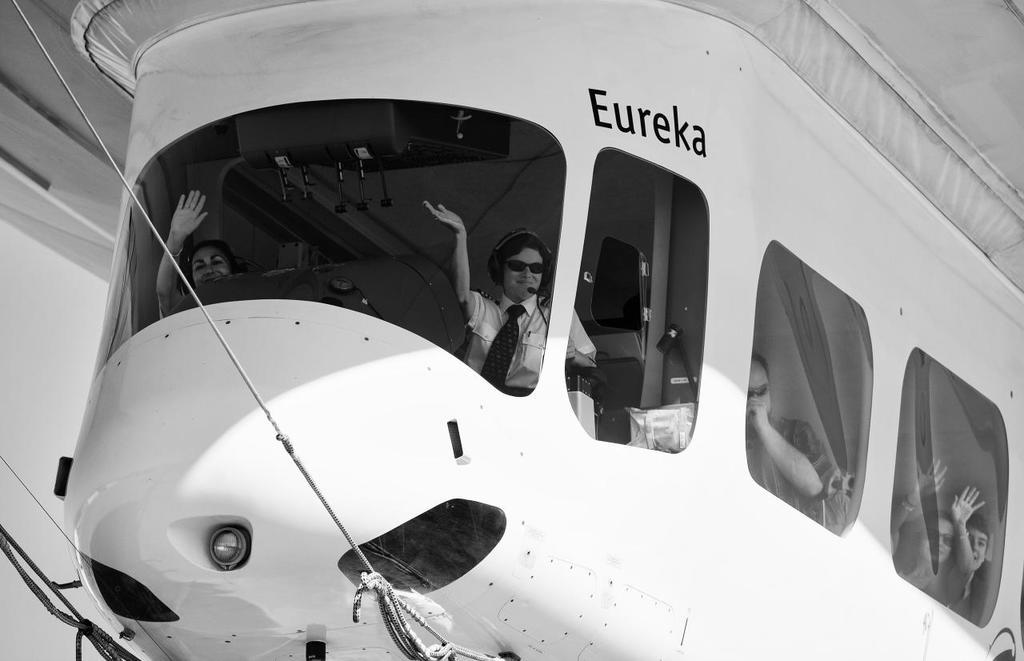What is the main subject of the image? The main subject of the image is an aircraft. Are there any people in the image? Yes, there are people inside the aircraft. What can be seen on the aircraft? There is text on the aircraft. What object is present in the image that is not part of the aircraft? There is a rope in the image. What is visible towards the left side of the image? There is a wall towards the left of the image. What type of cake is being served on the aircraft in the image? There is no cake present in the image; it features an aircraft with people inside and a rope nearby. Can you see a chessboard on the wall towards the left of the image? There is no chessboard visible in the image; only a wall is present towards the left side. 